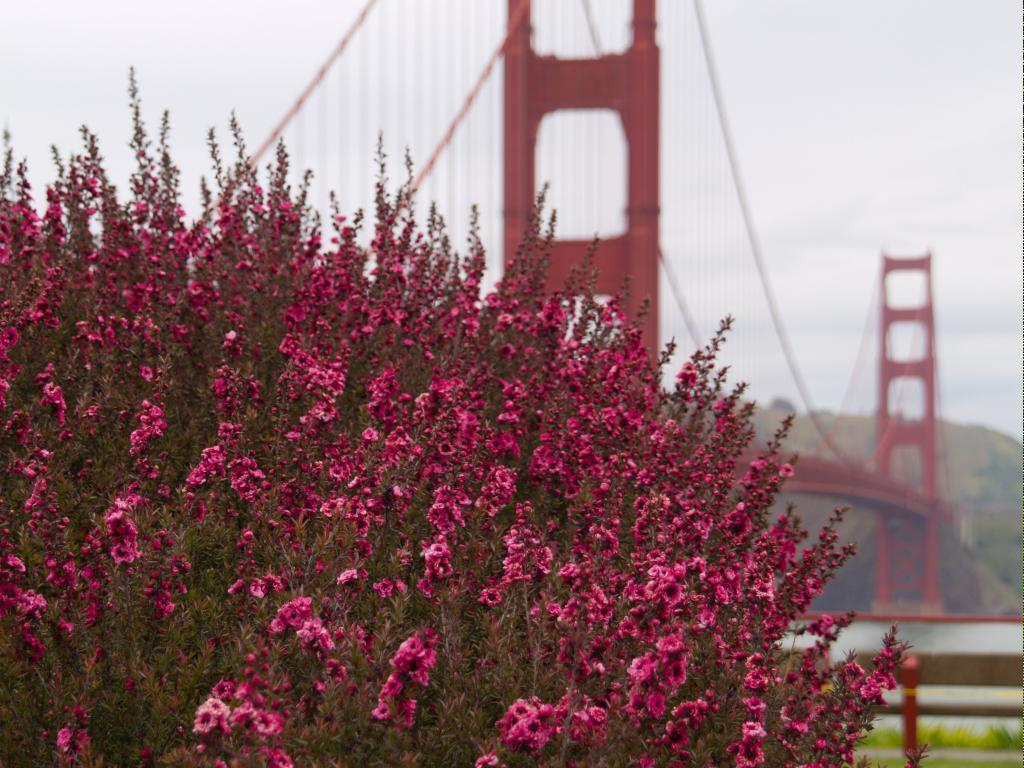Where was the image taken? The image was clicked outside. What is the main subject in the middle of the image? There is a bridge and a tree in the middle of the image. What can be seen at the top of the image? There is sky visible at the top of the image. What is special about the tree in the image? The tree has pink flowers. What type of thrill can be seen in the image? There is no thrill present in the image; it features a bridge, a tree with pink flowers, and the sky. Is there a fire visible in the image? No, there is no fire present in the image. 